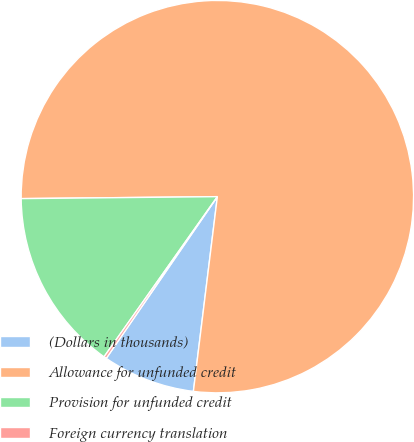Convert chart. <chart><loc_0><loc_0><loc_500><loc_500><pie_chart><fcel>(Dollars in thousands)<fcel>Allowance for unfunded credit<fcel>Provision for unfunded credit<fcel>Foreign currency translation<nl><fcel>7.63%<fcel>77.11%<fcel>15.04%<fcel>0.22%<nl></chart> 